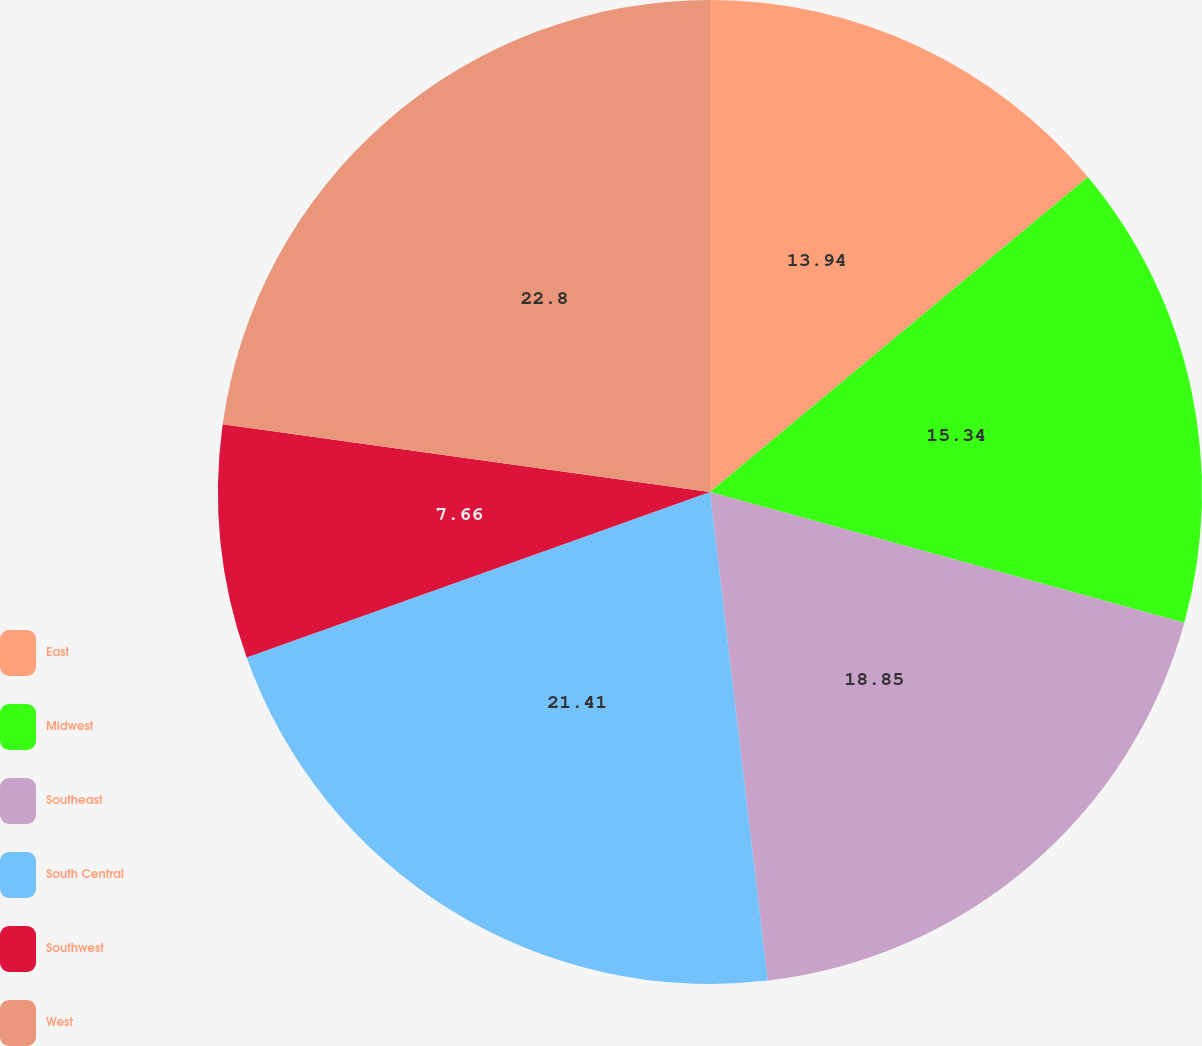Convert chart to OTSL. <chart><loc_0><loc_0><loc_500><loc_500><pie_chart><fcel>East<fcel>Midwest<fcel>Southeast<fcel>South Central<fcel>Southwest<fcel>West<nl><fcel>13.94%<fcel>15.34%<fcel>18.85%<fcel>21.41%<fcel>7.66%<fcel>22.8%<nl></chart> 